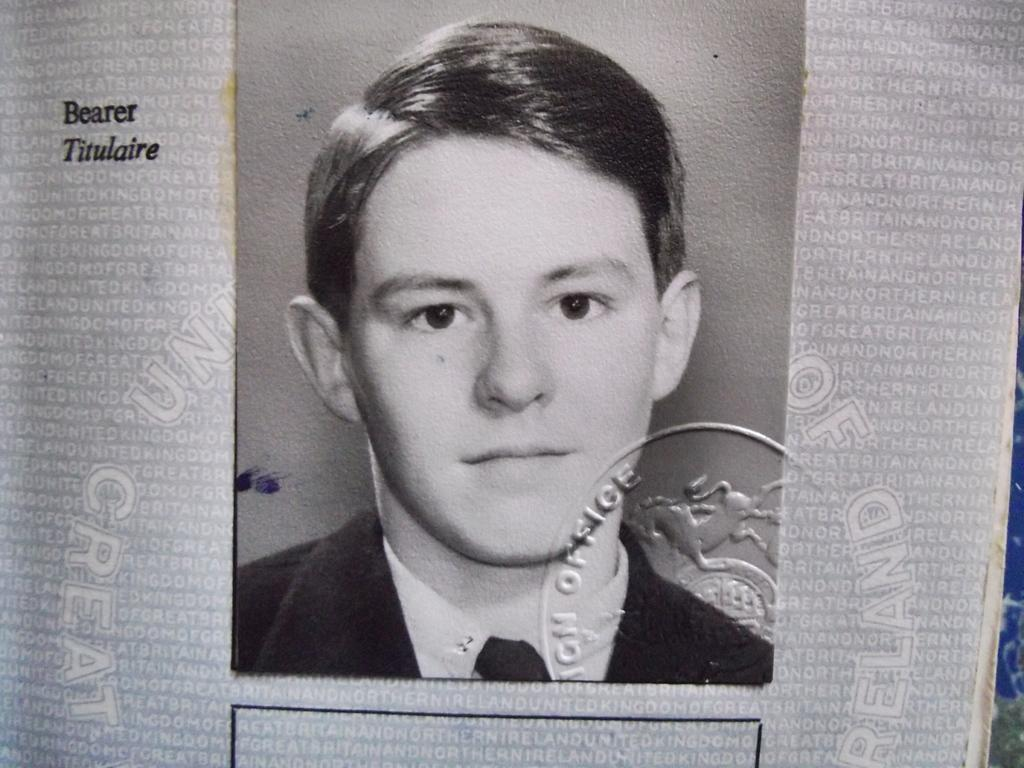What type of photo is present in the image? There is a black and white passport size photo in the image. How is the photo attached to the paper? The photo is pasted on a paper. What can be seen on the paper besides the photo? There are watermarks on the paper. What is present on the photo itself? There is a stamp on the photograph. Can you see any squirrels interacting with the cable in the image? There are no squirrels or cables present in the image. 